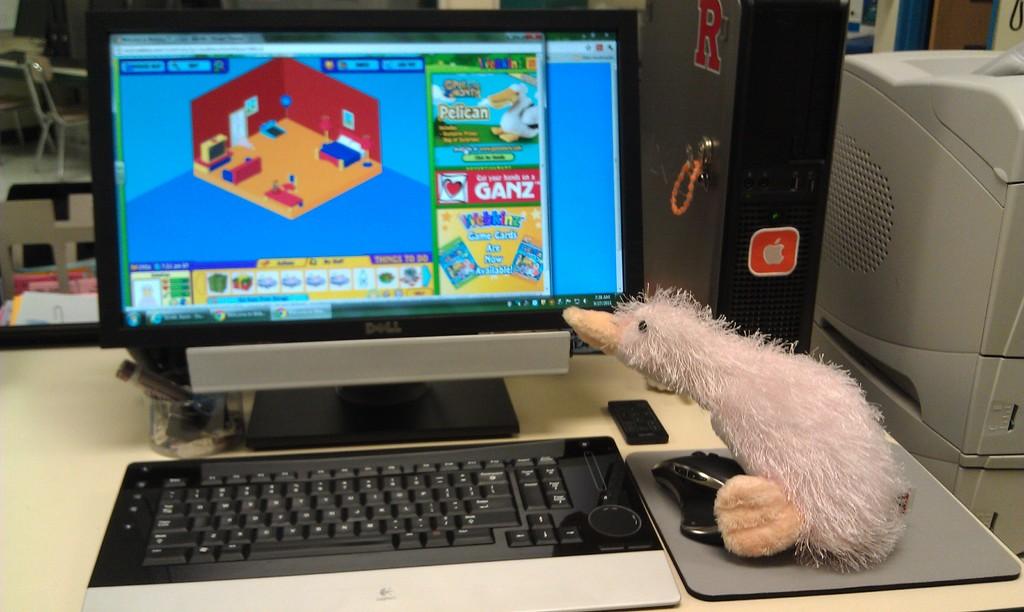What brand is this computer?
Provide a succinct answer. Dell. 